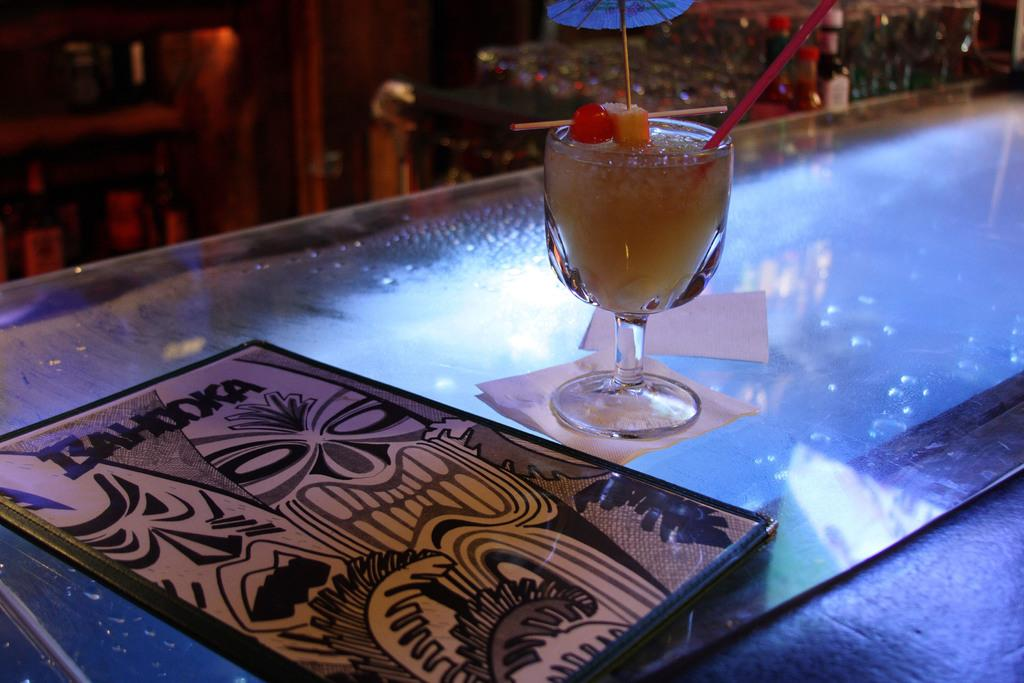What is inside the glass that is visible in the image? There is a drink in the glass that is visible in the image. What other items can be seen on the table in the image? There are tissues and a menu card visible on the table in the image. Where are the glass, tissues, and menu card located in the image? The glass, tissues, and menu card are placed on a table in the image. What can be seen in the background of the image? There are bottles visible in the background of the image. What type of cherries are being held by the hands in the image? There are no cherries or hands present in the image. 